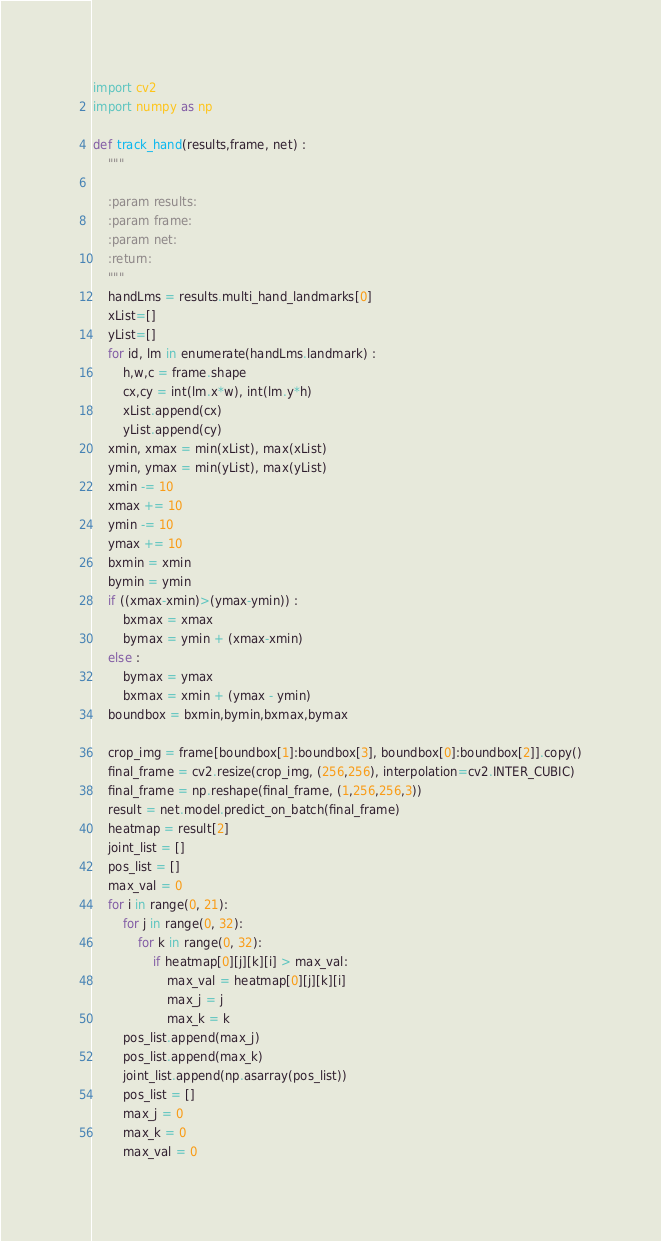<code> <loc_0><loc_0><loc_500><loc_500><_Python_>import cv2
import numpy as np

def track_hand(results,frame, net) :
    """

    :param results:
    :param frame:
    :param net:
    :return:
    """
    handLms = results.multi_hand_landmarks[0]
    xList=[]
    yList=[]
    for id, lm in enumerate(handLms.landmark) :
        h,w,c = frame.shape
        cx,cy = int(lm.x*w), int(lm.y*h)
        xList.append(cx)
        yList.append(cy)
    xmin, xmax = min(xList), max(xList)
    ymin, ymax = min(yList), max(yList)
    xmin -= 10
    xmax += 10
    ymin -= 10
    ymax += 10
    bxmin = xmin
    bymin = ymin
    if ((xmax-xmin)>(ymax-ymin)) :
        bxmax = xmax
        bymax = ymin + (xmax-xmin)
    else :
        bymax = ymax
        bxmax = xmin + (ymax - ymin)
    boundbox = bxmin,bymin,bxmax,bymax

    crop_img = frame[boundbox[1]:boundbox[3], boundbox[0]:boundbox[2]].copy()
    final_frame = cv2.resize(crop_img, (256,256), interpolation=cv2.INTER_CUBIC)
    final_frame = np.reshape(final_frame, (1,256,256,3))
    result = net.model.predict_on_batch(final_frame)
    heatmap = result[2]
    joint_list = []
    pos_list = []
    max_val = 0
    for i in range(0, 21):
        for j in range(0, 32):
            for k in range(0, 32):
                if heatmap[0][j][k][i] > max_val:
                    max_val = heatmap[0][j][k][i]
                    max_j = j
                    max_k = k
        pos_list.append(max_j)
        pos_list.append(max_k)
        joint_list.append(np.asarray(pos_list))
        pos_list = []
        max_j = 0
        max_k = 0
        max_val = 0</code> 